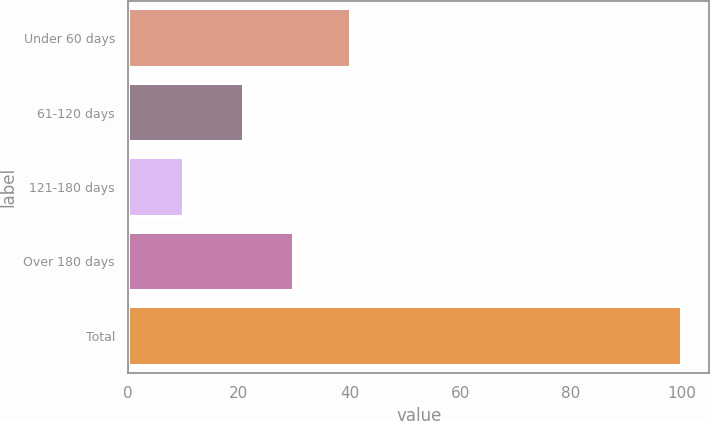Convert chart. <chart><loc_0><loc_0><loc_500><loc_500><bar_chart><fcel>Under 60 days<fcel>61-120 days<fcel>121-180 days<fcel>Over 180 days<fcel>Total<nl><fcel>40.3<fcel>21<fcel>10.1<fcel>29.99<fcel>100<nl></chart> 